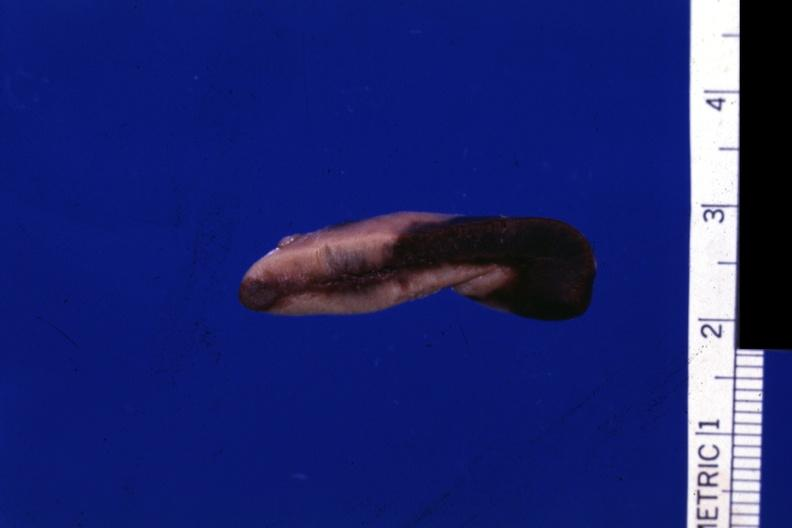s adrenal present?
Answer the question using a single word or phrase. Yes 